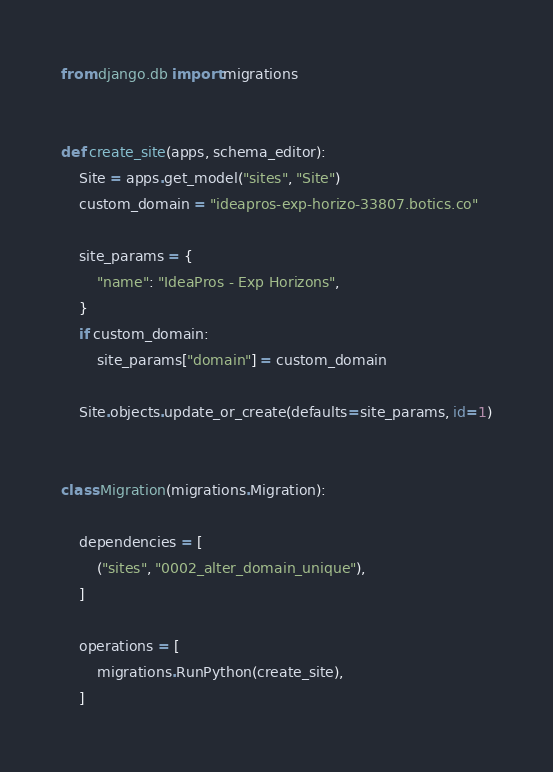<code> <loc_0><loc_0><loc_500><loc_500><_Python_>from django.db import migrations


def create_site(apps, schema_editor):
    Site = apps.get_model("sites", "Site")
    custom_domain = "ideapros-exp-horizo-33807.botics.co"

    site_params = {
        "name": "IdeaPros - Exp Horizons",
    }
    if custom_domain:
        site_params["domain"] = custom_domain

    Site.objects.update_or_create(defaults=site_params, id=1)


class Migration(migrations.Migration):

    dependencies = [
        ("sites", "0002_alter_domain_unique"),
    ]

    operations = [
        migrations.RunPython(create_site),
    ]
</code> 